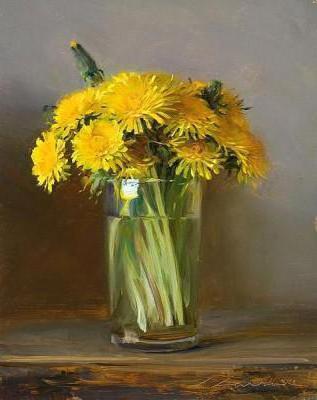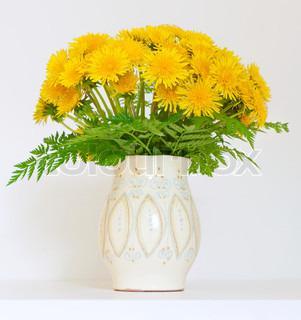The first image is the image on the left, the second image is the image on the right. Considering the images on both sides, is "The white vase is filled with yellow flowers." valid? Answer yes or no. Yes. 